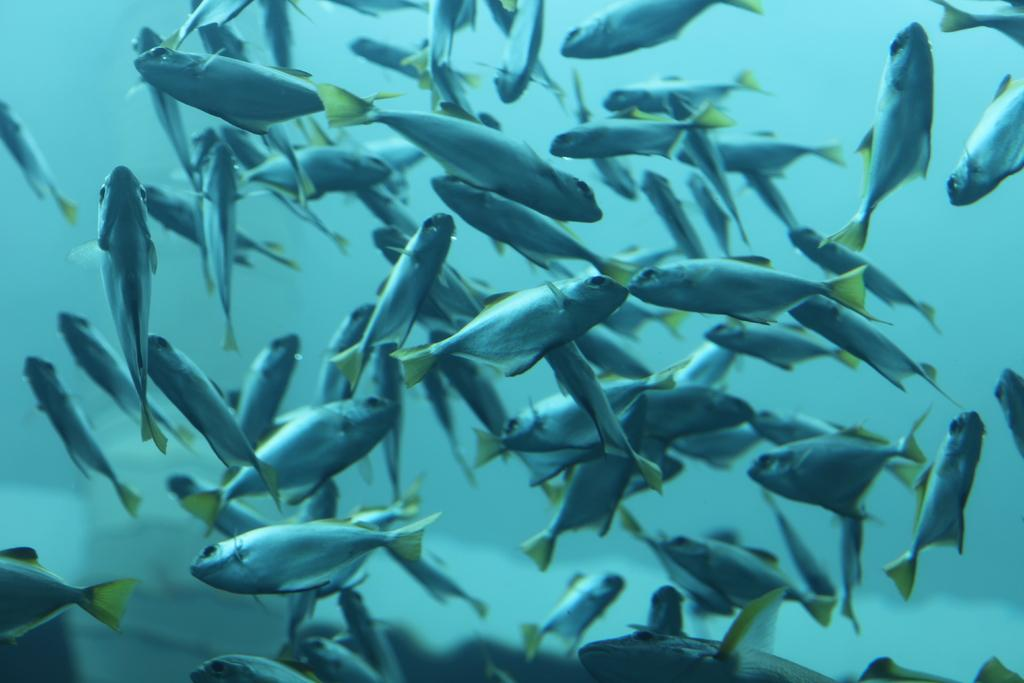What type of animals can be seen in the image? There are fishes in the image. Where are the fishes located? The fishes are in the water. What type of teaching materials can be seen in the image? There are no teaching materials present in the image; it features fishes in the water. What type of crate is visible in the image? There is no crate present in the image; it features fishes in the water. 